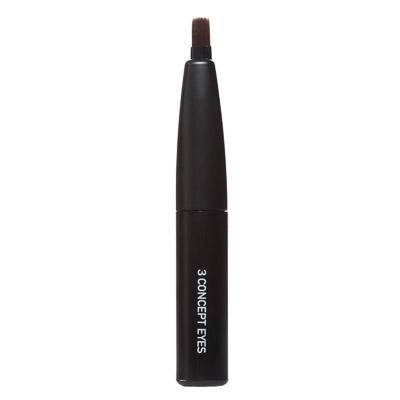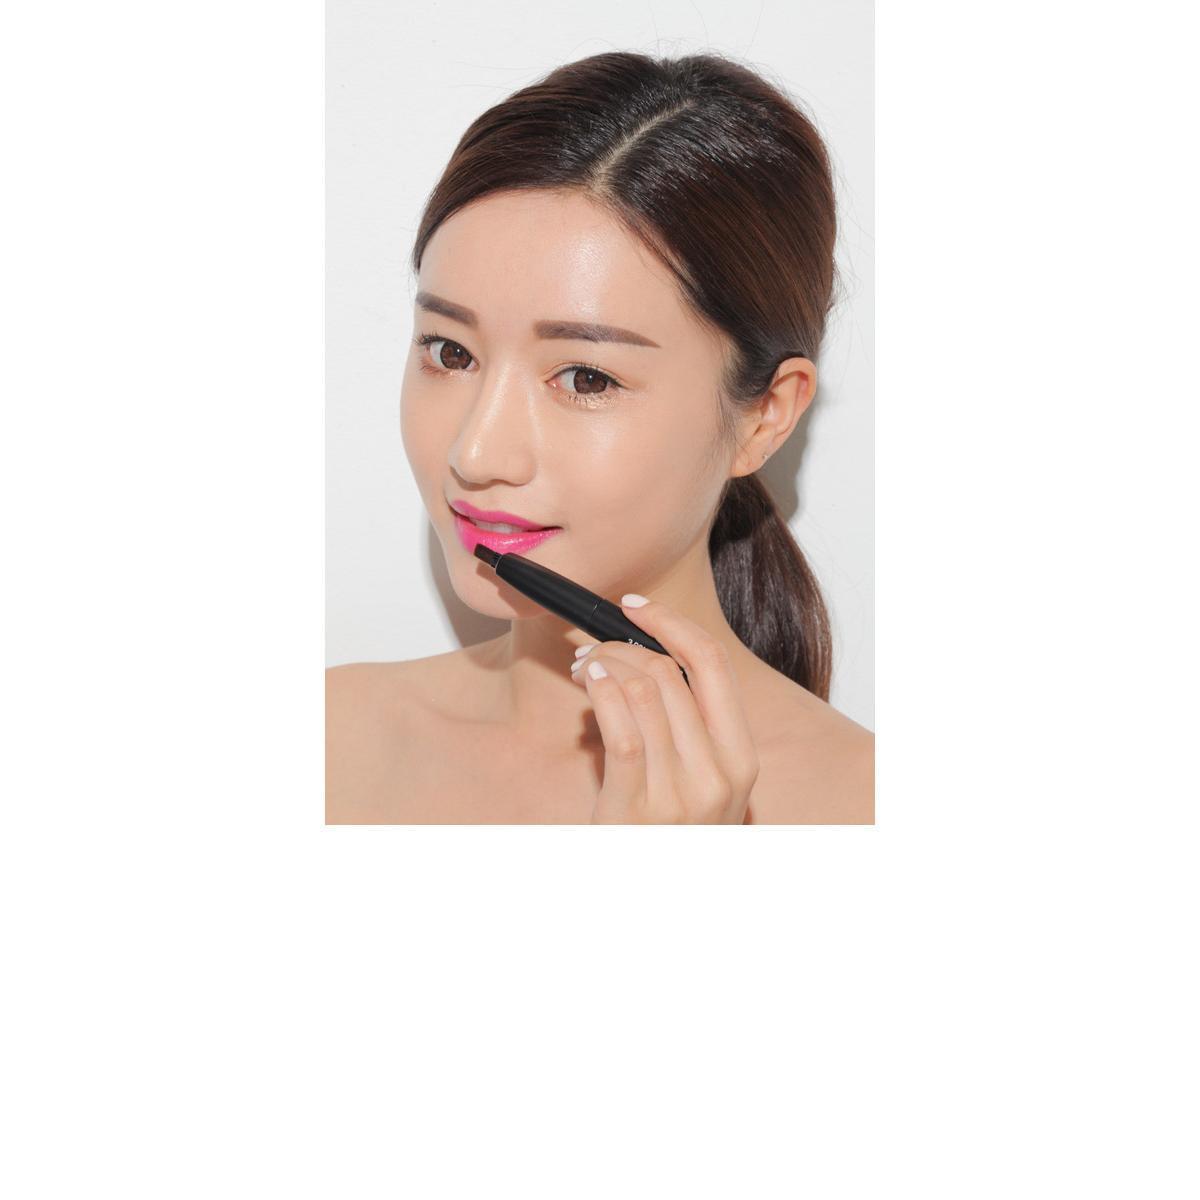The first image is the image on the left, the second image is the image on the right. Evaluate the accuracy of this statement regarding the images: "One image has three lips.". Is it true? Answer yes or no. No. 